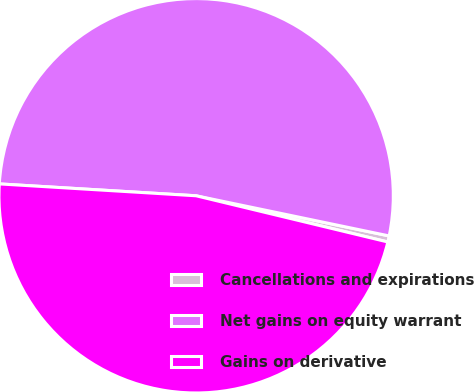Convert chart. <chart><loc_0><loc_0><loc_500><loc_500><pie_chart><fcel>Cancellations and expirations<fcel>Net gains on equity warrant<fcel>Gains on derivative<nl><fcel>0.5%<fcel>52.3%<fcel>47.19%<nl></chart> 